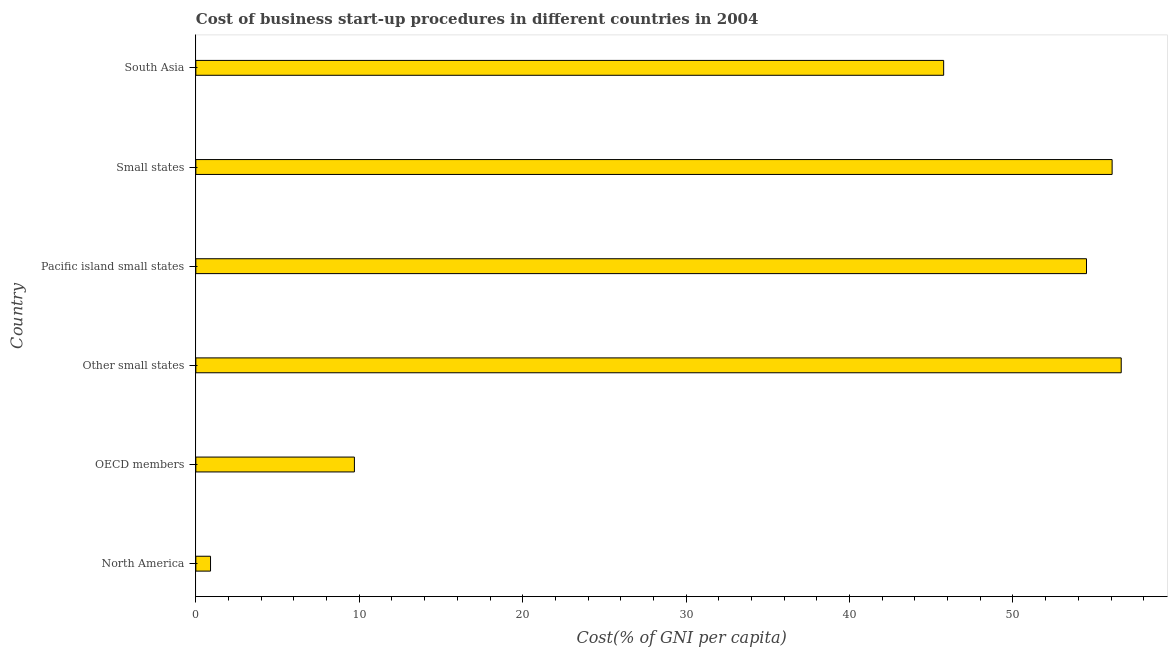Does the graph contain any zero values?
Your response must be concise. No. Does the graph contain grids?
Your answer should be compact. No. What is the title of the graph?
Offer a terse response. Cost of business start-up procedures in different countries in 2004. What is the label or title of the X-axis?
Your answer should be very brief. Cost(% of GNI per capita). What is the label or title of the Y-axis?
Give a very brief answer. Country. What is the cost of business startup procedures in Other small states?
Provide a short and direct response. 56.62. Across all countries, what is the maximum cost of business startup procedures?
Your answer should be compact. 56.62. In which country was the cost of business startup procedures maximum?
Your answer should be compact. Other small states. What is the sum of the cost of business startup procedures?
Your response must be concise. 223.56. What is the difference between the cost of business startup procedures in OECD members and Small states?
Your response must be concise. -46.37. What is the average cost of business startup procedures per country?
Offer a terse response. 37.26. What is the median cost of business startup procedures?
Give a very brief answer. 50.13. In how many countries, is the cost of business startup procedures greater than 2 %?
Offer a terse response. 5. What is the difference between the highest and the second highest cost of business startup procedures?
Provide a succinct answer. 0.56. Is the sum of the cost of business startup procedures in North America and Small states greater than the maximum cost of business startup procedures across all countries?
Your answer should be compact. Yes. What is the difference between the highest and the lowest cost of business startup procedures?
Ensure brevity in your answer.  55.73. In how many countries, is the cost of business startup procedures greater than the average cost of business startup procedures taken over all countries?
Offer a very short reply. 4. How many bars are there?
Keep it short and to the point. 6. Are all the bars in the graph horizontal?
Keep it short and to the point. Yes. What is the difference between two consecutive major ticks on the X-axis?
Give a very brief answer. 10. What is the Cost(% of GNI per capita) of North America?
Provide a succinct answer. 0.9. What is the Cost(% of GNI per capita) of OECD members?
Your answer should be compact. 9.7. What is the Cost(% of GNI per capita) of Other small states?
Provide a short and direct response. 56.62. What is the Cost(% of GNI per capita) of Pacific island small states?
Make the answer very short. 54.5. What is the Cost(% of GNI per capita) of Small states?
Offer a terse response. 56.07. What is the Cost(% of GNI per capita) of South Asia?
Make the answer very short. 45.76. What is the difference between the Cost(% of GNI per capita) in North America and OECD members?
Make the answer very short. -8.8. What is the difference between the Cost(% of GNI per capita) in North America and Other small states?
Your answer should be compact. -55.73. What is the difference between the Cost(% of GNI per capita) in North America and Pacific island small states?
Make the answer very short. -53.6. What is the difference between the Cost(% of GNI per capita) in North America and Small states?
Your answer should be compact. -55.17. What is the difference between the Cost(% of GNI per capita) in North America and South Asia?
Your answer should be compact. -44.86. What is the difference between the Cost(% of GNI per capita) in OECD members and Other small states?
Keep it short and to the point. -46.92. What is the difference between the Cost(% of GNI per capita) in OECD members and Pacific island small states?
Offer a terse response. -44.8. What is the difference between the Cost(% of GNI per capita) in OECD members and Small states?
Offer a terse response. -46.37. What is the difference between the Cost(% of GNI per capita) in OECD members and South Asia?
Ensure brevity in your answer.  -36.06. What is the difference between the Cost(% of GNI per capita) in Other small states and Pacific island small states?
Make the answer very short. 2.12. What is the difference between the Cost(% of GNI per capita) in Other small states and Small states?
Your answer should be very brief. 0.56. What is the difference between the Cost(% of GNI per capita) in Other small states and South Asia?
Provide a short and direct response. 10.87. What is the difference between the Cost(% of GNI per capita) in Pacific island small states and Small states?
Give a very brief answer. -1.57. What is the difference between the Cost(% of GNI per capita) in Pacific island small states and South Asia?
Give a very brief answer. 8.74. What is the difference between the Cost(% of GNI per capita) in Small states and South Asia?
Make the answer very short. 10.31. What is the ratio of the Cost(% of GNI per capita) in North America to that in OECD members?
Provide a succinct answer. 0.09. What is the ratio of the Cost(% of GNI per capita) in North America to that in Other small states?
Your answer should be very brief. 0.02. What is the ratio of the Cost(% of GNI per capita) in North America to that in Pacific island small states?
Offer a terse response. 0.02. What is the ratio of the Cost(% of GNI per capita) in North America to that in Small states?
Offer a terse response. 0.02. What is the ratio of the Cost(% of GNI per capita) in North America to that in South Asia?
Give a very brief answer. 0.02. What is the ratio of the Cost(% of GNI per capita) in OECD members to that in Other small states?
Make the answer very short. 0.17. What is the ratio of the Cost(% of GNI per capita) in OECD members to that in Pacific island small states?
Provide a succinct answer. 0.18. What is the ratio of the Cost(% of GNI per capita) in OECD members to that in Small states?
Give a very brief answer. 0.17. What is the ratio of the Cost(% of GNI per capita) in OECD members to that in South Asia?
Keep it short and to the point. 0.21. What is the ratio of the Cost(% of GNI per capita) in Other small states to that in Pacific island small states?
Ensure brevity in your answer.  1.04. What is the ratio of the Cost(% of GNI per capita) in Other small states to that in Small states?
Your response must be concise. 1.01. What is the ratio of the Cost(% of GNI per capita) in Other small states to that in South Asia?
Offer a terse response. 1.24. What is the ratio of the Cost(% of GNI per capita) in Pacific island small states to that in South Asia?
Give a very brief answer. 1.19. What is the ratio of the Cost(% of GNI per capita) in Small states to that in South Asia?
Your answer should be very brief. 1.23. 